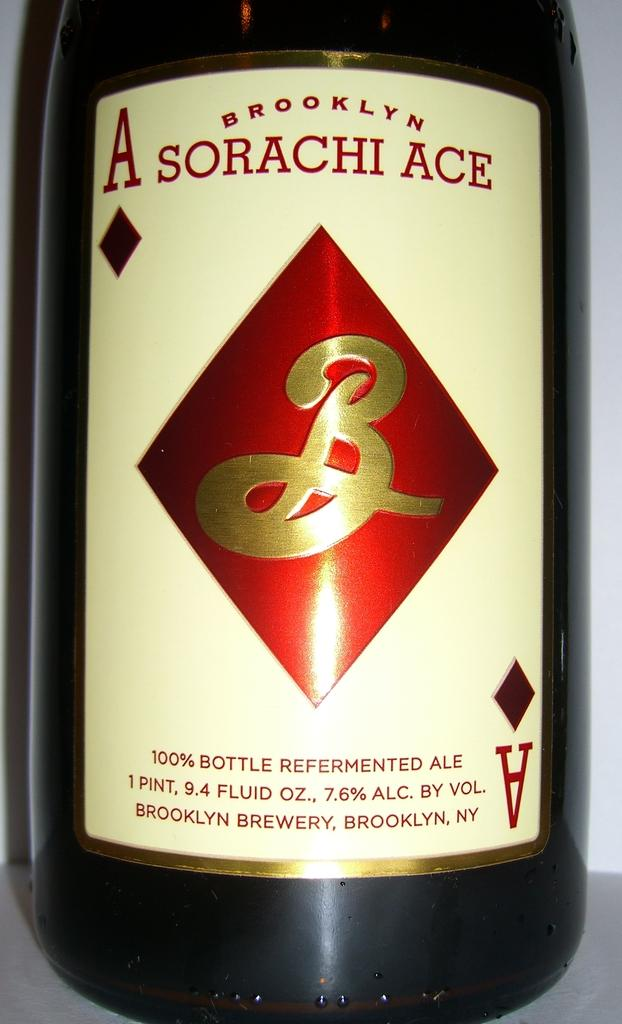<image>
Relay a brief, clear account of the picture shown. A bottle of Ale with the title Brooklyn Asorachi Ace written on it. 